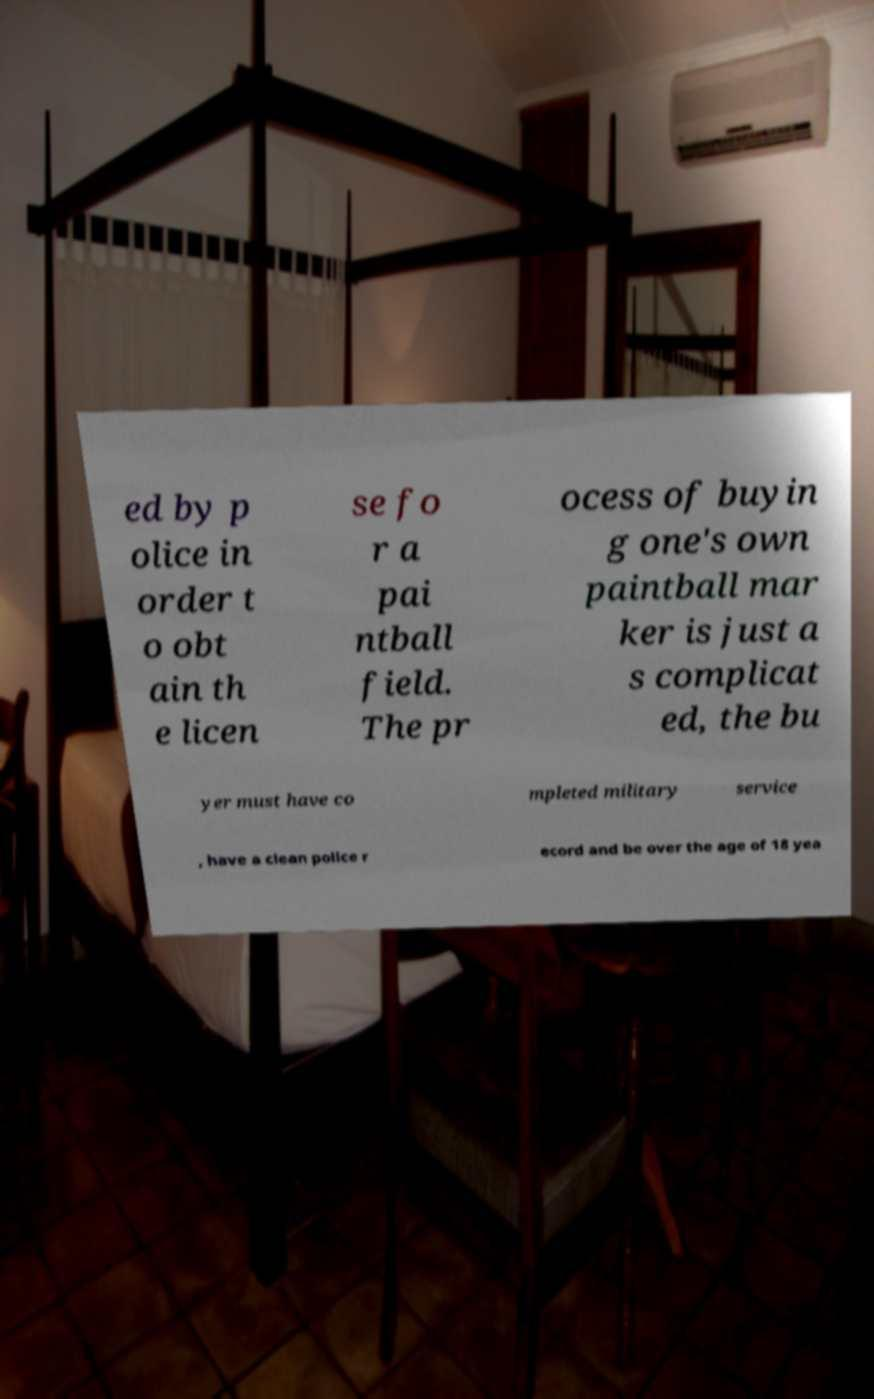There's text embedded in this image that I need extracted. Can you transcribe it verbatim? ed by p olice in order t o obt ain th e licen se fo r a pai ntball field. The pr ocess of buyin g one's own paintball mar ker is just a s complicat ed, the bu yer must have co mpleted military service , have a clean police r ecord and be over the age of 18 yea 